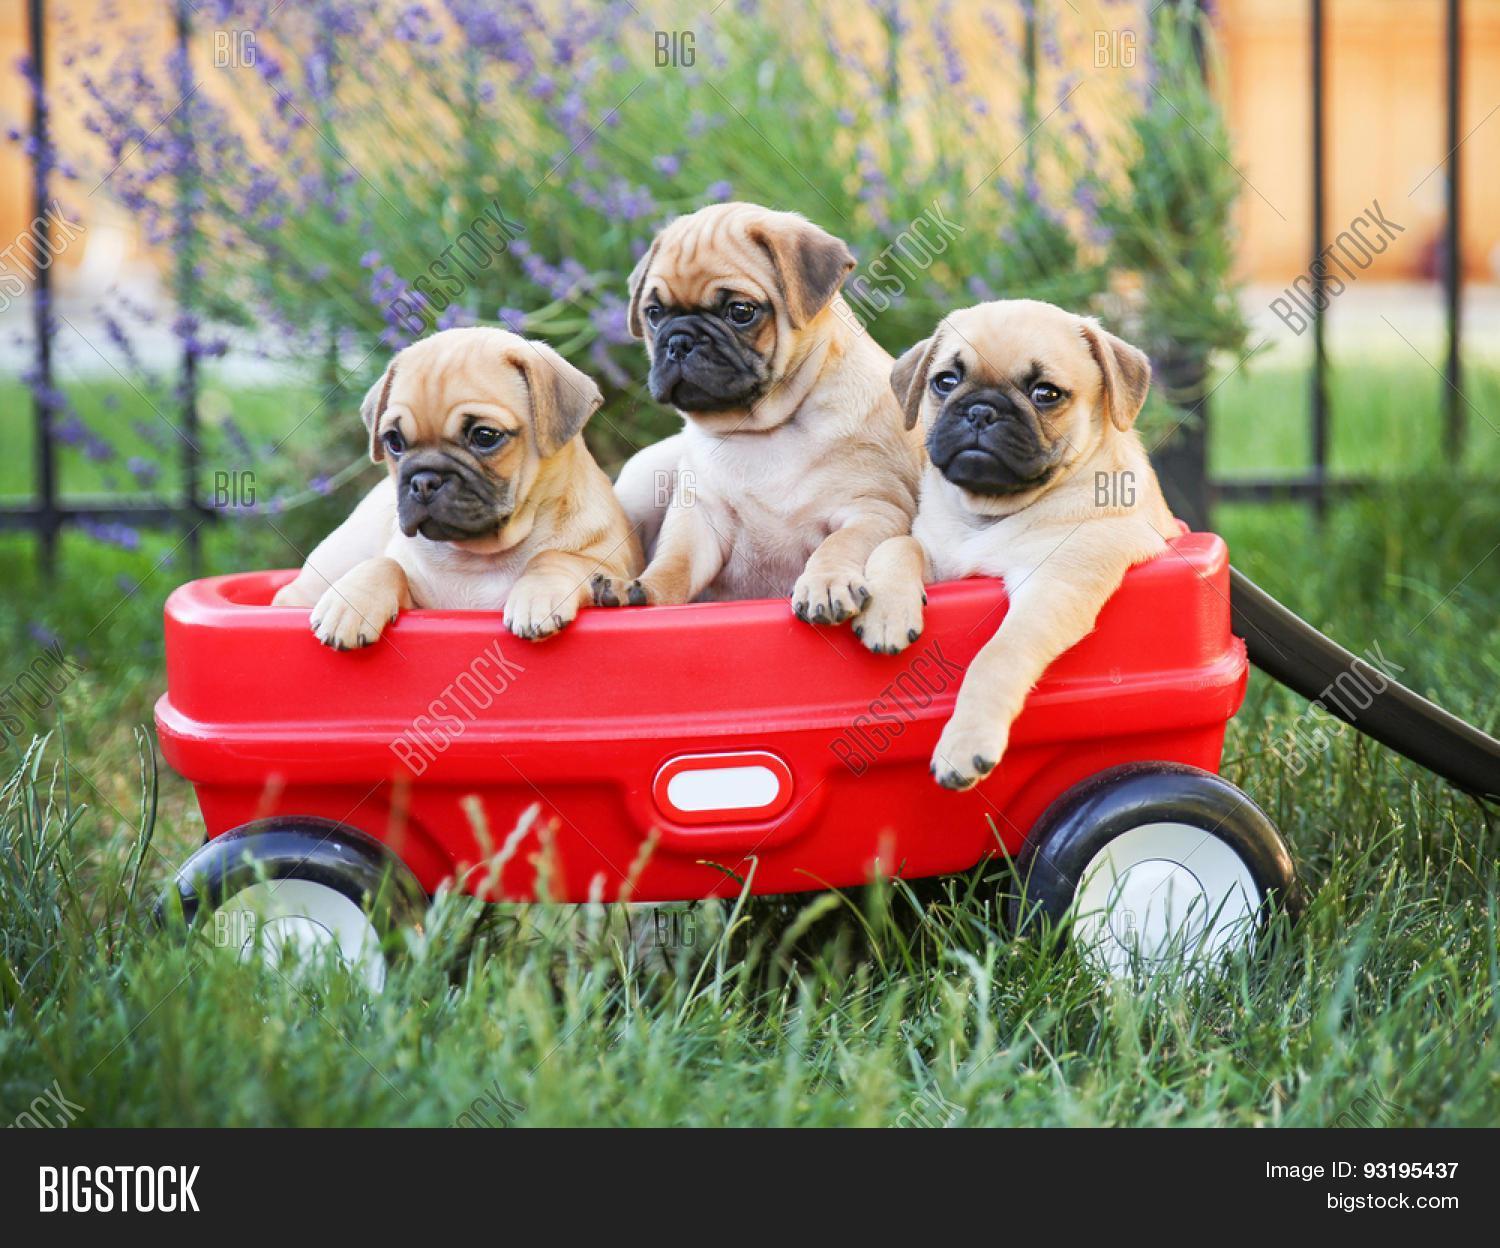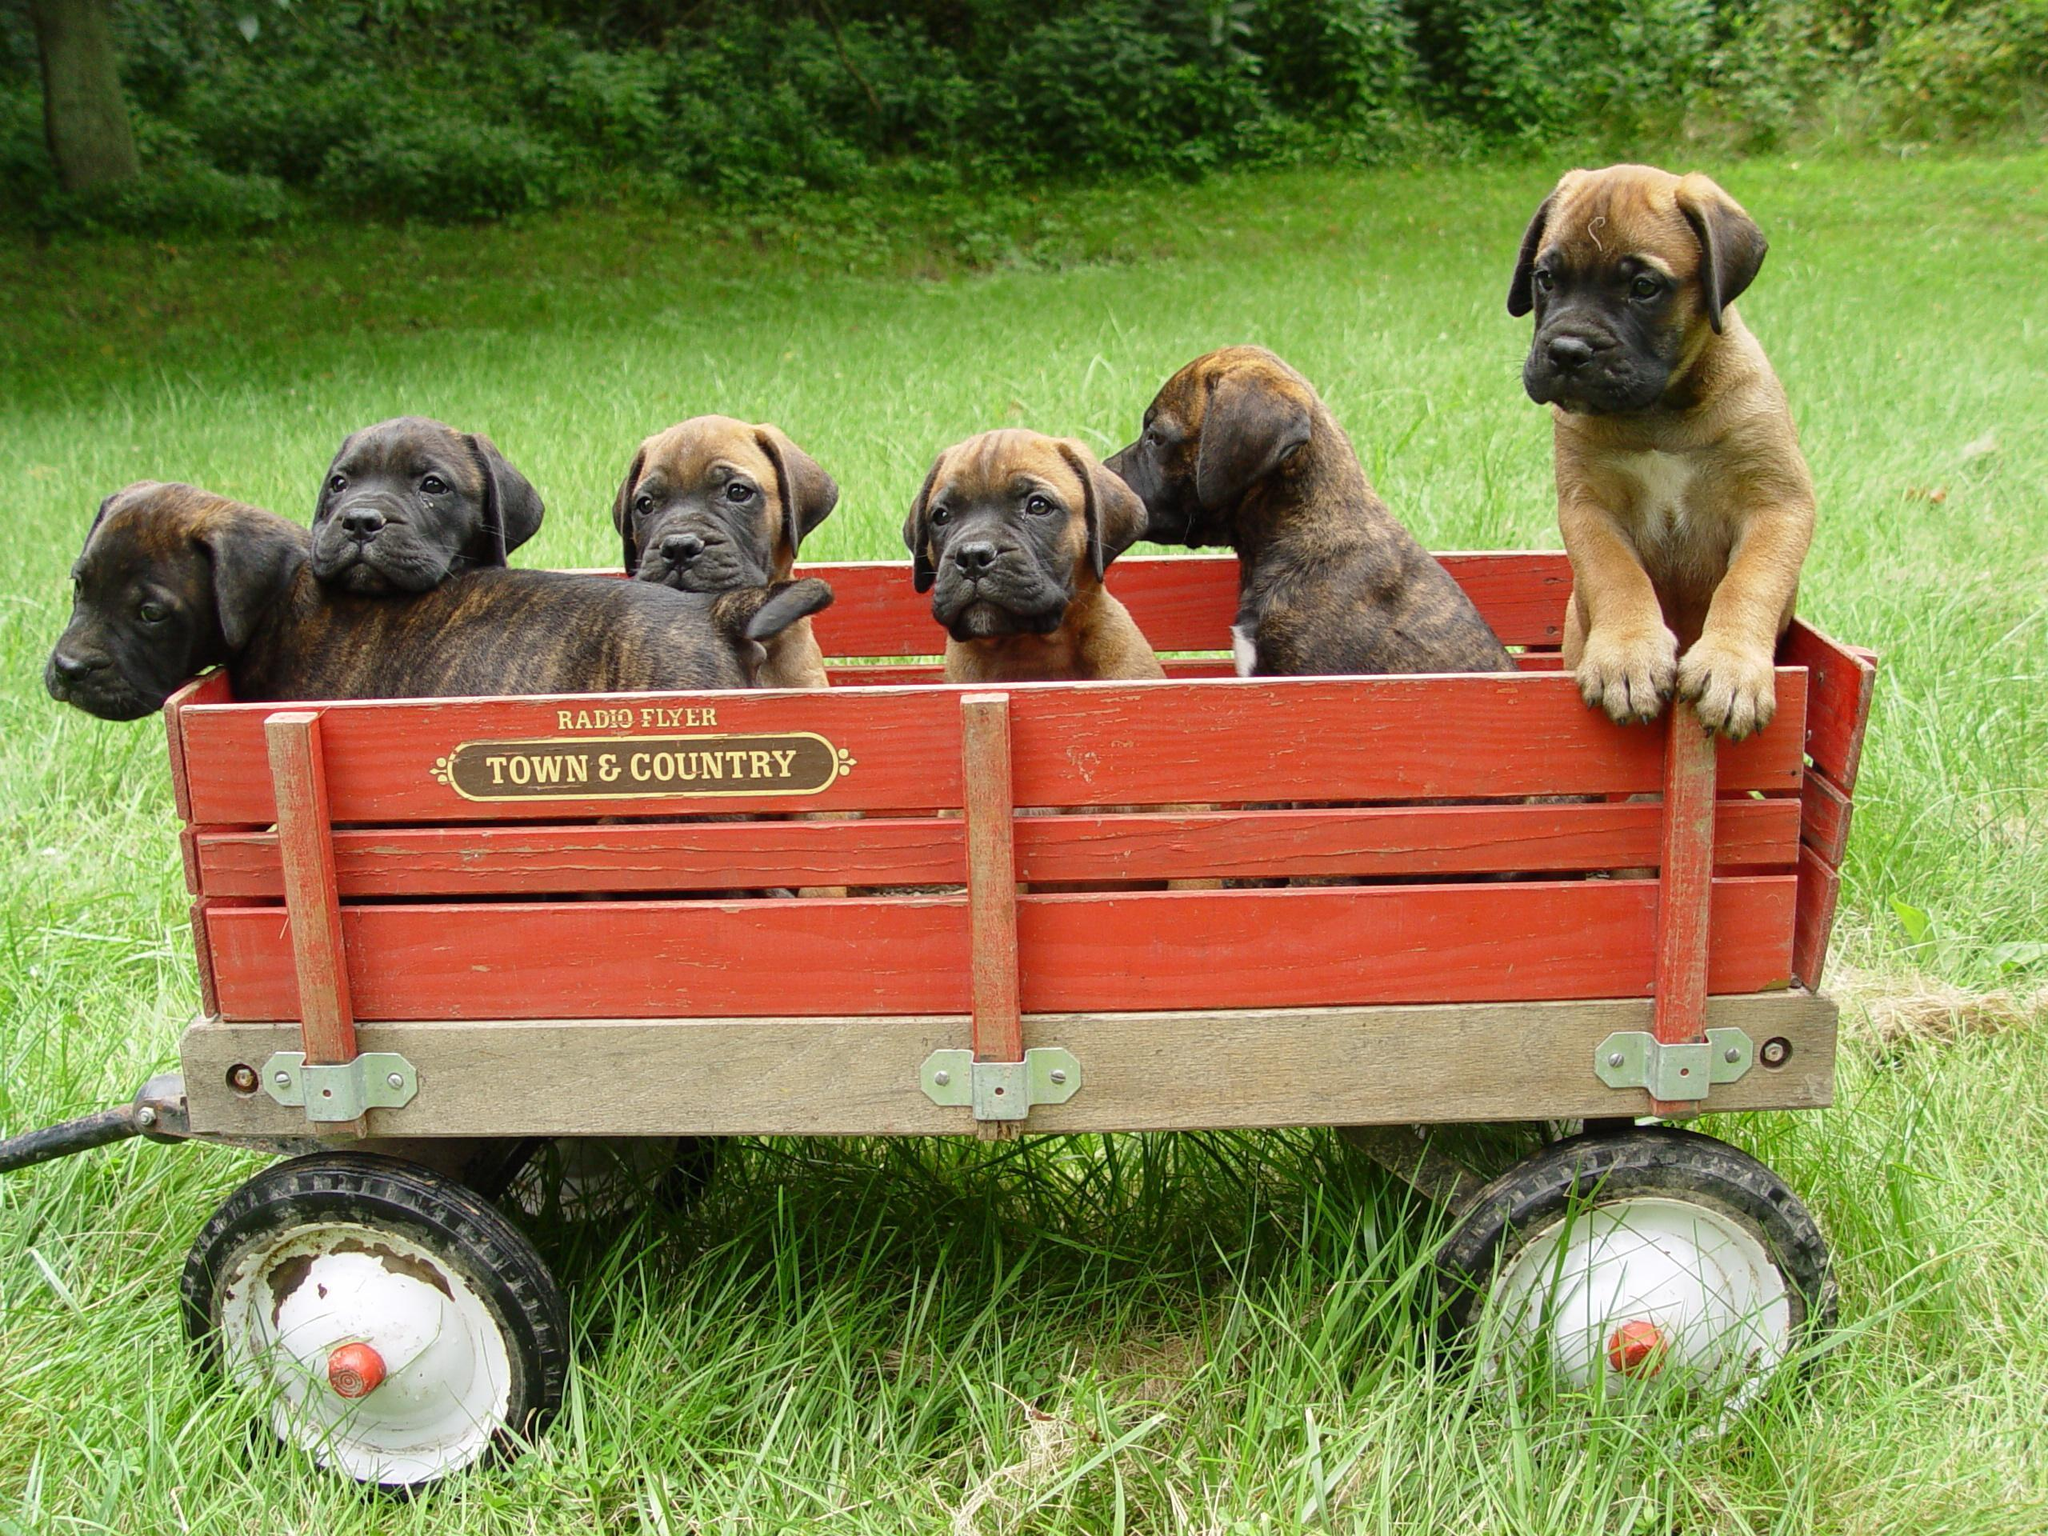The first image is the image on the left, the second image is the image on the right. Examine the images to the left and right. Is the description "One of the four pugs is wearing a hat." accurate? Answer yes or no. No. The first image is the image on the left, the second image is the image on the right. Analyze the images presented: Is the assertion "The right image includes at least one standing beige pug on a leash, and the left image features three forward-facing beige pugs wearing some type of attire." valid? Answer yes or no. No. 